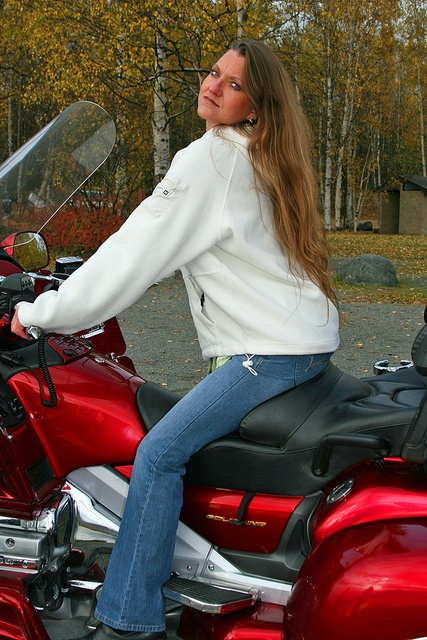Describe the objects in this image and their specific colors. I can see motorcycle in black, maroon, and gray tones and people in black, lightgray, blue, and darkgray tones in this image. 